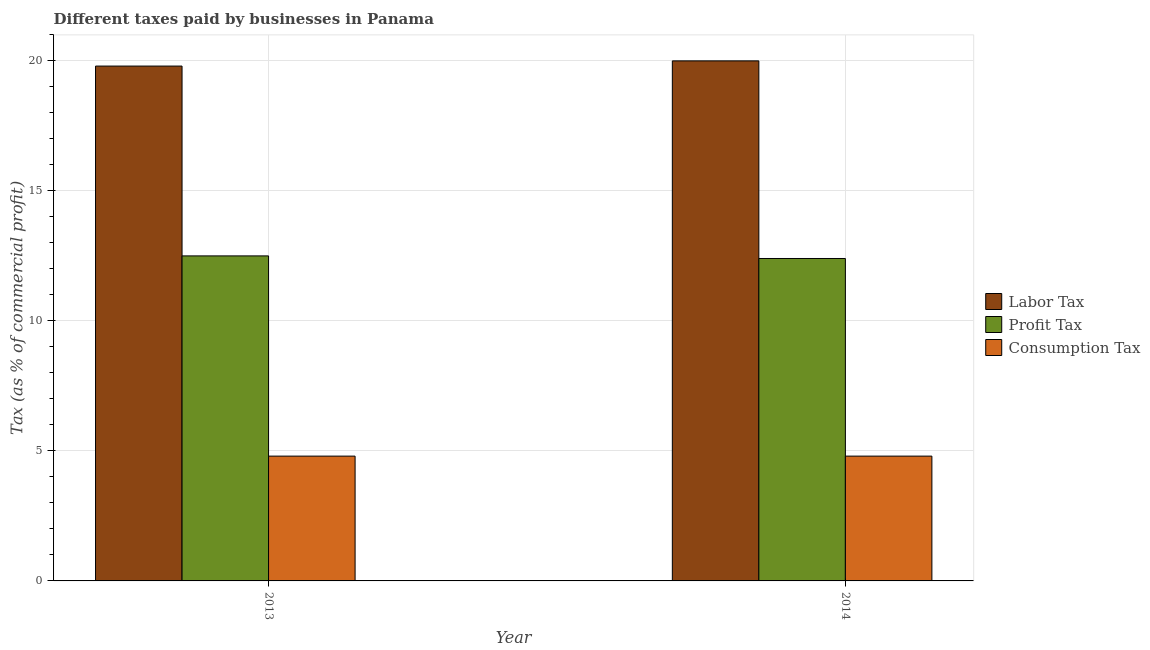How many different coloured bars are there?
Keep it short and to the point. 3. How many groups of bars are there?
Keep it short and to the point. 2. Are the number of bars per tick equal to the number of legend labels?
Your answer should be compact. Yes. How many bars are there on the 2nd tick from the right?
Give a very brief answer. 3. What is the label of the 2nd group of bars from the left?
Ensure brevity in your answer.  2014. What is the percentage of labor tax in 2014?
Your answer should be very brief. 20. Across all years, what is the maximum percentage of labor tax?
Provide a short and direct response. 20. Across all years, what is the minimum percentage of profit tax?
Give a very brief answer. 12.4. What is the total percentage of consumption tax in the graph?
Ensure brevity in your answer.  9.6. What is the difference between the percentage of profit tax in 2013 and that in 2014?
Make the answer very short. 0.1. What is the difference between the percentage of profit tax in 2013 and the percentage of consumption tax in 2014?
Make the answer very short. 0.1. What is the average percentage of profit tax per year?
Provide a short and direct response. 12.45. What is the ratio of the percentage of profit tax in 2013 to that in 2014?
Provide a succinct answer. 1.01. Is the percentage of consumption tax in 2013 less than that in 2014?
Provide a short and direct response. No. What does the 2nd bar from the left in 2014 represents?
Make the answer very short. Profit Tax. What does the 3rd bar from the right in 2013 represents?
Keep it short and to the point. Labor Tax. How many bars are there?
Provide a succinct answer. 6. Does the graph contain grids?
Keep it short and to the point. Yes. What is the title of the graph?
Ensure brevity in your answer.  Different taxes paid by businesses in Panama. What is the label or title of the X-axis?
Your response must be concise. Year. What is the label or title of the Y-axis?
Offer a terse response. Tax (as % of commercial profit). What is the Tax (as % of commercial profit) of Labor Tax in 2013?
Offer a terse response. 19.8. What is the Tax (as % of commercial profit) in Consumption Tax in 2014?
Keep it short and to the point. 4.8. Across all years, what is the maximum Tax (as % of commercial profit) in Profit Tax?
Your answer should be very brief. 12.5. Across all years, what is the maximum Tax (as % of commercial profit) of Consumption Tax?
Provide a short and direct response. 4.8. Across all years, what is the minimum Tax (as % of commercial profit) in Labor Tax?
Your response must be concise. 19.8. Across all years, what is the minimum Tax (as % of commercial profit) of Profit Tax?
Make the answer very short. 12.4. What is the total Tax (as % of commercial profit) in Labor Tax in the graph?
Give a very brief answer. 39.8. What is the total Tax (as % of commercial profit) of Profit Tax in the graph?
Ensure brevity in your answer.  24.9. What is the total Tax (as % of commercial profit) in Consumption Tax in the graph?
Your answer should be very brief. 9.6. What is the difference between the Tax (as % of commercial profit) in Profit Tax in 2013 and that in 2014?
Offer a very short reply. 0.1. What is the difference between the Tax (as % of commercial profit) of Consumption Tax in 2013 and that in 2014?
Offer a very short reply. 0. What is the difference between the Tax (as % of commercial profit) in Labor Tax in 2013 and the Tax (as % of commercial profit) in Consumption Tax in 2014?
Keep it short and to the point. 15. What is the difference between the Tax (as % of commercial profit) in Profit Tax in 2013 and the Tax (as % of commercial profit) in Consumption Tax in 2014?
Provide a short and direct response. 7.7. What is the average Tax (as % of commercial profit) of Labor Tax per year?
Your response must be concise. 19.9. What is the average Tax (as % of commercial profit) in Profit Tax per year?
Keep it short and to the point. 12.45. In the year 2013, what is the difference between the Tax (as % of commercial profit) in Labor Tax and Tax (as % of commercial profit) in Consumption Tax?
Ensure brevity in your answer.  15. In the year 2014, what is the difference between the Tax (as % of commercial profit) in Labor Tax and Tax (as % of commercial profit) in Consumption Tax?
Your answer should be very brief. 15.2. What is the ratio of the Tax (as % of commercial profit) of Labor Tax in 2013 to that in 2014?
Make the answer very short. 0.99. What is the ratio of the Tax (as % of commercial profit) of Consumption Tax in 2013 to that in 2014?
Give a very brief answer. 1. What is the difference between the highest and the second highest Tax (as % of commercial profit) of Consumption Tax?
Provide a succinct answer. 0. What is the difference between the highest and the lowest Tax (as % of commercial profit) in Labor Tax?
Keep it short and to the point. 0.2. What is the difference between the highest and the lowest Tax (as % of commercial profit) in Profit Tax?
Your answer should be very brief. 0.1. What is the difference between the highest and the lowest Tax (as % of commercial profit) in Consumption Tax?
Your answer should be very brief. 0. 